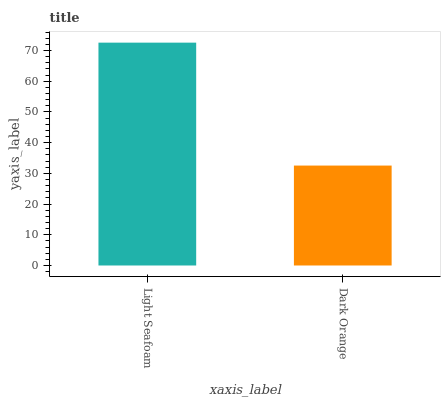Is Dark Orange the minimum?
Answer yes or no. Yes. Is Light Seafoam the maximum?
Answer yes or no. Yes. Is Dark Orange the maximum?
Answer yes or no. No. Is Light Seafoam greater than Dark Orange?
Answer yes or no. Yes. Is Dark Orange less than Light Seafoam?
Answer yes or no. Yes. Is Dark Orange greater than Light Seafoam?
Answer yes or no. No. Is Light Seafoam less than Dark Orange?
Answer yes or no. No. Is Light Seafoam the high median?
Answer yes or no. Yes. Is Dark Orange the low median?
Answer yes or no. Yes. Is Dark Orange the high median?
Answer yes or no. No. Is Light Seafoam the low median?
Answer yes or no. No. 